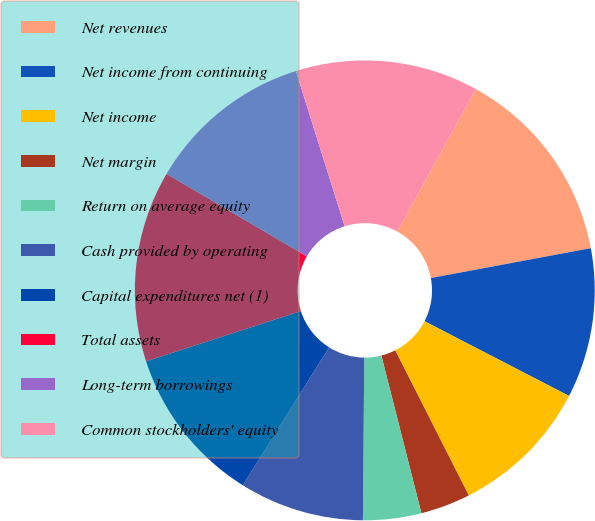Convert chart to OTSL. <chart><loc_0><loc_0><loc_500><loc_500><pie_chart><fcel>Net revenues<fcel>Net income from continuing<fcel>Net income<fcel>Net margin<fcel>Return on average equity<fcel>Cash provided by operating<fcel>Capital expenditures net (1)<fcel>Total assets<fcel>Long-term borrowings<fcel>Common stockholders' equity<nl><fcel>14.04%<fcel>10.53%<fcel>9.94%<fcel>3.51%<fcel>4.09%<fcel>8.77%<fcel>11.11%<fcel>13.45%<fcel>11.7%<fcel>12.87%<nl></chart> 